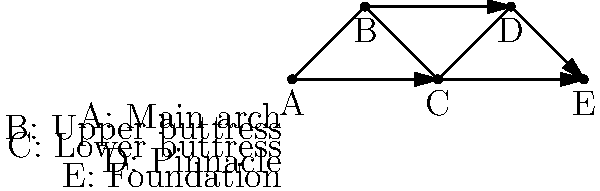In the network diagram representing the structural elements of a Gothic cathedral's flying buttress system, which node represents the component that directly transfers the lateral thrust from the main arch to the lower buttress? To answer this question, we need to analyze the network diagram and understand the structural components of a Gothic cathedral's flying buttress system:

1. Node A represents the main arch of the cathedral, which exerts lateral thrust outwards.
2. Node B represents the upper buttress, which is the primary component that receives the lateral thrust from the main arch.
3. Node C represents the lower buttress, which supports the upper buttress and transfers the load to the ground.
4. Node D represents the pinnacle, which adds weight to the buttress system for stability.
5. Node E represents the foundation, which anchors the entire structure to the ground.

The question asks about the component that directly transfers the lateral thrust from the main arch to the lower buttress. Following the network diagram:

1. The arrow goes from A (main arch) to B (upper buttress).
2. Then from B (upper buttress) to C (lower buttress).

Therefore, the upper buttress (Node B) is the component that directly transfers the lateral thrust from the main arch to the lower buttress.
Answer: B (Upper buttress) 